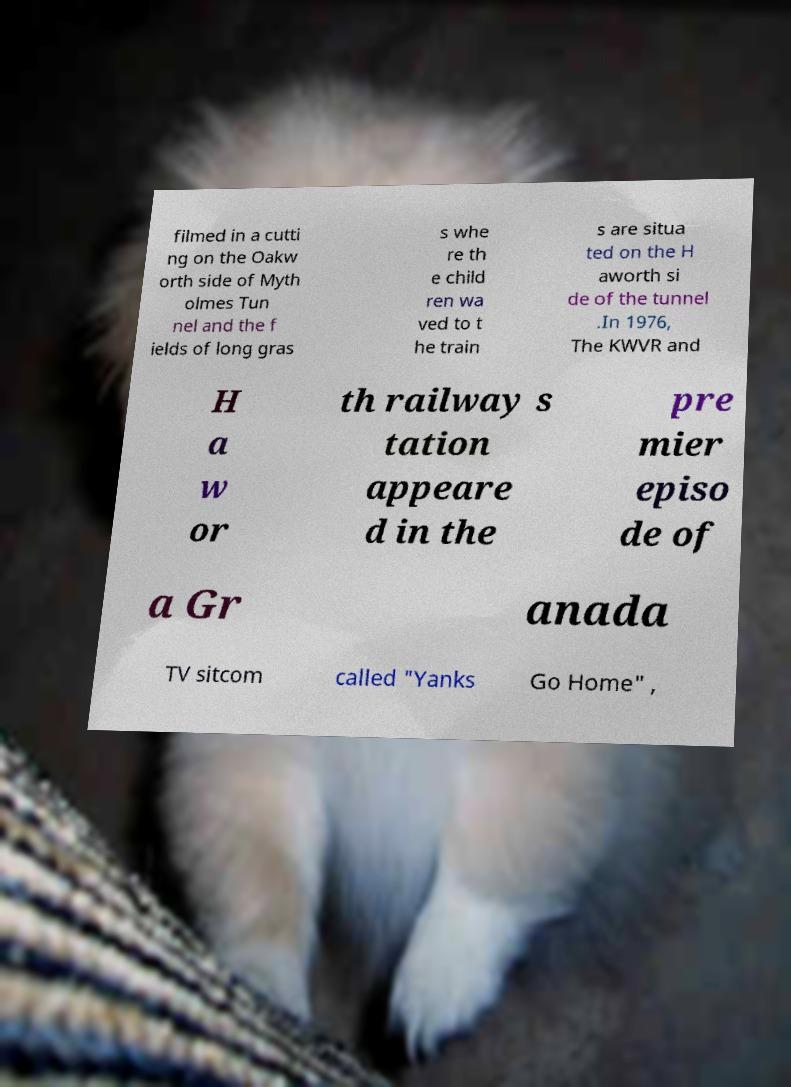What messages or text are displayed in this image? I need them in a readable, typed format. filmed in a cutti ng on the Oakw orth side of Myth olmes Tun nel and the f ields of long gras s whe re th e child ren wa ved to t he train s are situa ted on the H aworth si de of the tunnel .In 1976, The KWVR and H a w or th railway s tation appeare d in the pre mier episo de of a Gr anada TV sitcom called "Yanks Go Home" , 